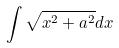<formula> <loc_0><loc_0><loc_500><loc_500>\int \sqrt { x ^ { 2 } + a ^ { 2 } } d x</formula> 